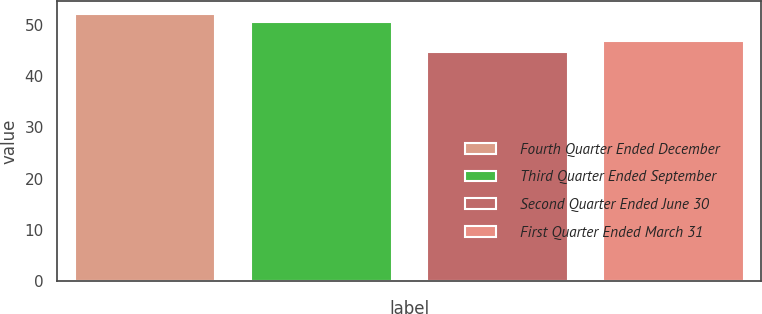Convert chart to OTSL. <chart><loc_0><loc_0><loc_500><loc_500><bar_chart><fcel>Fourth Quarter Ended December<fcel>Third Quarter Ended September<fcel>Second Quarter Ended June 30<fcel>First Quarter Ended March 31<nl><fcel>52.01<fcel>50.58<fcel>44.73<fcel>46.79<nl></chart> 